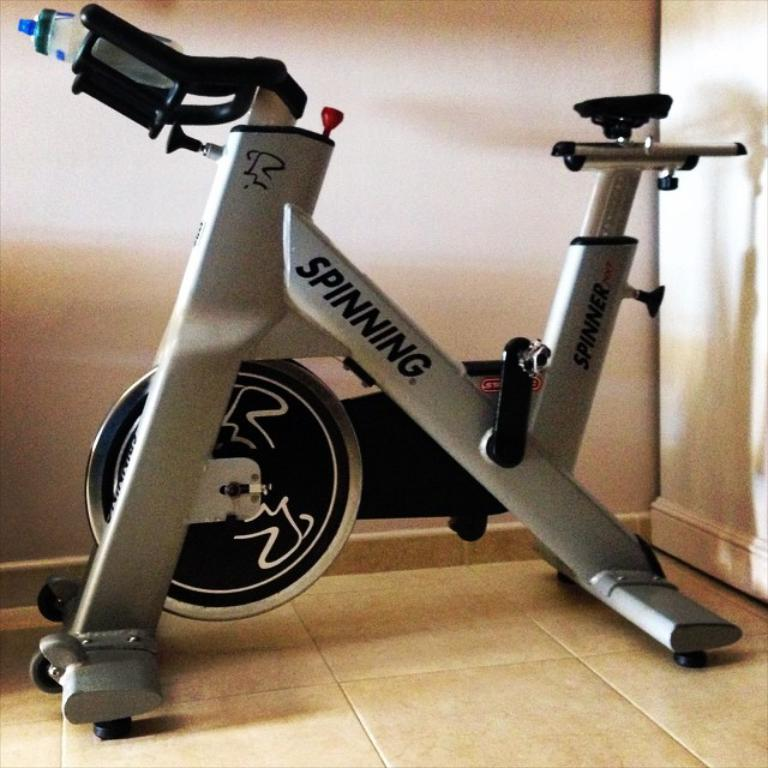What type of exercise equipment is in the image? There is an exercise cycle in the image. What is the color of the exercise cycle? The exercise cycle is black and ash in color. What is placed on the exercise cycle? There is a bottle on the exercise cycle. What can be seen in the background of the image? There is a wall in the background of the image. How many apples are being used to power the engine in the image? There is no engine or apples present in the image; it features an exercise cycle and a bottle. 